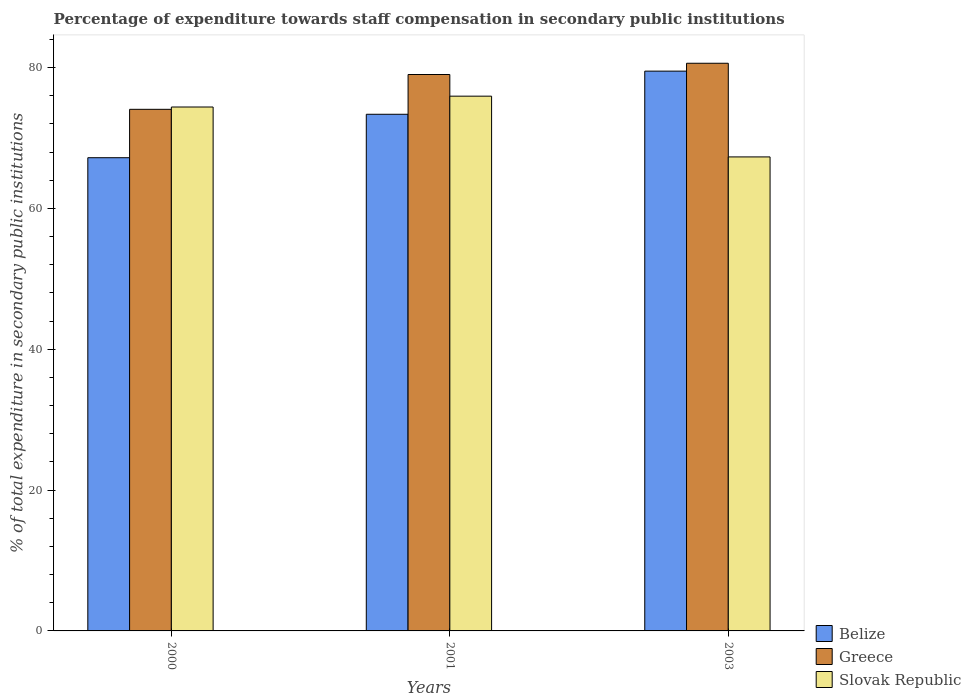How many different coloured bars are there?
Offer a terse response. 3. Are the number of bars per tick equal to the number of legend labels?
Give a very brief answer. Yes. Are the number of bars on each tick of the X-axis equal?
Your response must be concise. Yes. How many bars are there on the 1st tick from the right?
Provide a succinct answer. 3. What is the percentage of expenditure towards staff compensation in Greece in 2003?
Provide a short and direct response. 80.61. Across all years, what is the maximum percentage of expenditure towards staff compensation in Slovak Republic?
Your answer should be compact. 75.94. Across all years, what is the minimum percentage of expenditure towards staff compensation in Slovak Republic?
Offer a very short reply. 67.31. In which year was the percentage of expenditure towards staff compensation in Belize minimum?
Keep it short and to the point. 2000. What is the total percentage of expenditure towards staff compensation in Greece in the graph?
Give a very brief answer. 233.7. What is the difference between the percentage of expenditure towards staff compensation in Belize in 2000 and that in 2001?
Your response must be concise. -6.17. What is the difference between the percentage of expenditure towards staff compensation in Greece in 2000 and the percentage of expenditure towards staff compensation in Belize in 2001?
Make the answer very short. 0.7. What is the average percentage of expenditure towards staff compensation in Belize per year?
Offer a very short reply. 73.35. In the year 2001, what is the difference between the percentage of expenditure towards staff compensation in Belize and percentage of expenditure towards staff compensation in Slovak Republic?
Give a very brief answer. -2.57. In how many years, is the percentage of expenditure towards staff compensation in Greece greater than 60 %?
Provide a short and direct response. 3. What is the ratio of the percentage of expenditure towards staff compensation in Greece in 2001 to that in 2003?
Provide a succinct answer. 0.98. Is the difference between the percentage of expenditure towards staff compensation in Belize in 2000 and 2003 greater than the difference between the percentage of expenditure towards staff compensation in Slovak Republic in 2000 and 2003?
Offer a very short reply. No. What is the difference between the highest and the second highest percentage of expenditure towards staff compensation in Greece?
Give a very brief answer. 1.6. What is the difference between the highest and the lowest percentage of expenditure towards staff compensation in Slovak Republic?
Offer a terse response. 8.63. Is the sum of the percentage of expenditure towards staff compensation in Belize in 2000 and 2003 greater than the maximum percentage of expenditure towards staff compensation in Greece across all years?
Ensure brevity in your answer.  Yes. What does the 2nd bar from the left in 2000 represents?
Ensure brevity in your answer.  Greece. What does the 3rd bar from the right in 2000 represents?
Make the answer very short. Belize. How many bars are there?
Your answer should be compact. 9. Are all the bars in the graph horizontal?
Make the answer very short. No. How many years are there in the graph?
Ensure brevity in your answer.  3. Are the values on the major ticks of Y-axis written in scientific E-notation?
Offer a terse response. No. Does the graph contain grids?
Your answer should be very brief. No. Where does the legend appear in the graph?
Ensure brevity in your answer.  Bottom right. How many legend labels are there?
Your response must be concise. 3. How are the legend labels stacked?
Offer a very short reply. Vertical. What is the title of the graph?
Your answer should be compact. Percentage of expenditure towards staff compensation in secondary public institutions. What is the label or title of the X-axis?
Your answer should be very brief. Years. What is the label or title of the Y-axis?
Provide a succinct answer. % of total expenditure in secondary public institutions. What is the % of total expenditure in secondary public institutions in Belize in 2000?
Your answer should be very brief. 67.2. What is the % of total expenditure in secondary public institutions in Greece in 2000?
Make the answer very short. 74.07. What is the % of total expenditure in secondary public institutions of Slovak Republic in 2000?
Your answer should be very brief. 74.4. What is the % of total expenditure in secondary public institutions in Belize in 2001?
Offer a terse response. 73.37. What is the % of total expenditure in secondary public institutions in Greece in 2001?
Offer a very short reply. 79.02. What is the % of total expenditure in secondary public institutions of Slovak Republic in 2001?
Ensure brevity in your answer.  75.94. What is the % of total expenditure in secondary public institutions in Belize in 2003?
Give a very brief answer. 79.49. What is the % of total expenditure in secondary public institutions of Greece in 2003?
Your answer should be compact. 80.61. What is the % of total expenditure in secondary public institutions in Slovak Republic in 2003?
Your response must be concise. 67.31. Across all years, what is the maximum % of total expenditure in secondary public institutions in Belize?
Your answer should be very brief. 79.49. Across all years, what is the maximum % of total expenditure in secondary public institutions in Greece?
Your answer should be compact. 80.61. Across all years, what is the maximum % of total expenditure in secondary public institutions in Slovak Republic?
Give a very brief answer. 75.94. Across all years, what is the minimum % of total expenditure in secondary public institutions of Belize?
Make the answer very short. 67.2. Across all years, what is the minimum % of total expenditure in secondary public institutions in Greece?
Your answer should be very brief. 74.07. Across all years, what is the minimum % of total expenditure in secondary public institutions of Slovak Republic?
Provide a short and direct response. 67.31. What is the total % of total expenditure in secondary public institutions of Belize in the graph?
Ensure brevity in your answer.  220.06. What is the total % of total expenditure in secondary public institutions in Greece in the graph?
Provide a succinct answer. 233.7. What is the total % of total expenditure in secondary public institutions in Slovak Republic in the graph?
Offer a very short reply. 217.65. What is the difference between the % of total expenditure in secondary public institutions in Belize in 2000 and that in 2001?
Give a very brief answer. -6.17. What is the difference between the % of total expenditure in secondary public institutions in Greece in 2000 and that in 2001?
Keep it short and to the point. -4.94. What is the difference between the % of total expenditure in secondary public institutions of Slovak Republic in 2000 and that in 2001?
Your answer should be compact. -1.54. What is the difference between the % of total expenditure in secondary public institutions of Belize in 2000 and that in 2003?
Offer a very short reply. -12.3. What is the difference between the % of total expenditure in secondary public institutions of Greece in 2000 and that in 2003?
Provide a short and direct response. -6.54. What is the difference between the % of total expenditure in secondary public institutions of Slovak Republic in 2000 and that in 2003?
Your answer should be very brief. 7.09. What is the difference between the % of total expenditure in secondary public institutions in Belize in 2001 and that in 2003?
Make the answer very short. -6.13. What is the difference between the % of total expenditure in secondary public institutions in Greece in 2001 and that in 2003?
Make the answer very short. -1.6. What is the difference between the % of total expenditure in secondary public institutions of Slovak Republic in 2001 and that in 2003?
Provide a short and direct response. 8.63. What is the difference between the % of total expenditure in secondary public institutions of Belize in 2000 and the % of total expenditure in secondary public institutions of Greece in 2001?
Your answer should be compact. -11.82. What is the difference between the % of total expenditure in secondary public institutions in Belize in 2000 and the % of total expenditure in secondary public institutions in Slovak Republic in 2001?
Keep it short and to the point. -8.74. What is the difference between the % of total expenditure in secondary public institutions in Greece in 2000 and the % of total expenditure in secondary public institutions in Slovak Republic in 2001?
Your answer should be compact. -1.87. What is the difference between the % of total expenditure in secondary public institutions in Belize in 2000 and the % of total expenditure in secondary public institutions in Greece in 2003?
Your response must be concise. -13.41. What is the difference between the % of total expenditure in secondary public institutions in Belize in 2000 and the % of total expenditure in secondary public institutions in Slovak Republic in 2003?
Ensure brevity in your answer.  -0.11. What is the difference between the % of total expenditure in secondary public institutions in Greece in 2000 and the % of total expenditure in secondary public institutions in Slovak Republic in 2003?
Make the answer very short. 6.76. What is the difference between the % of total expenditure in secondary public institutions in Belize in 2001 and the % of total expenditure in secondary public institutions in Greece in 2003?
Make the answer very short. -7.24. What is the difference between the % of total expenditure in secondary public institutions in Belize in 2001 and the % of total expenditure in secondary public institutions in Slovak Republic in 2003?
Your response must be concise. 6.06. What is the difference between the % of total expenditure in secondary public institutions in Greece in 2001 and the % of total expenditure in secondary public institutions in Slovak Republic in 2003?
Your answer should be compact. 11.7. What is the average % of total expenditure in secondary public institutions in Belize per year?
Your answer should be very brief. 73.35. What is the average % of total expenditure in secondary public institutions of Greece per year?
Provide a succinct answer. 77.9. What is the average % of total expenditure in secondary public institutions in Slovak Republic per year?
Make the answer very short. 72.55. In the year 2000, what is the difference between the % of total expenditure in secondary public institutions in Belize and % of total expenditure in secondary public institutions in Greece?
Your response must be concise. -6.87. In the year 2000, what is the difference between the % of total expenditure in secondary public institutions in Belize and % of total expenditure in secondary public institutions in Slovak Republic?
Provide a succinct answer. -7.2. In the year 2000, what is the difference between the % of total expenditure in secondary public institutions in Greece and % of total expenditure in secondary public institutions in Slovak Republic?
Keep it short and to the point. -0.33. In the year 2001, what is the difference between the % of total expenditure in secondary public institutions of Belize and % of total expenditure in secondary public institutions of Greece?
Ensure brevity in your answer.  -5.65. In the year 2001, what is the difference between the % of total expenditure in secondary public institutions in Belize and % of total expenditure in secondary public institutions in Slovak Republic?
Provide a succinct answer. -2.57. In the year 2001, what is the difference between the % of total expenditure in secondary public institutions of Greece and % of total expenditure in secondary public institutions of Slovak Republic?
Offer a terse response. 3.08. In the year 2003, what is the difference between the % of total expenditure in secondary public institutions in Belize and % of total expenditure in secondary public institutions in Greece?
Provide a succinct answer. -1.12. In the year 2003, what is the difference between the % of total expenditure in secondary public institutions of Belize and % of total expenditure in secondary public institutions of Slovak Republic?
Offer a very short reply. 12.18. In the year 2003, what is the difference between the % of total expenditure in secondary public institutions in Greece and % of total expenditure in secondary public institutions in Slovak Republic?
Offer a terse response. 13.3. What is the ratio of the % of total expenditure in secondary public institutions of Belize in 2000 to that in 2001?
Your answer should be very brief. 0.92. What is the ratio of the % of total expenditure in secondary public institutions of Greece in 2000 to that in 2001?
Provide a succinct answer. 0.94. What is the ratio of the % of total expenditure in secondary public institutions in Slovak Republic in 2000 to that in 2001?
Provide a short and direct response. 0.98. What is the ratio of the % of total expenditure in secondary public institutions of Belize in 2000 to that in 2003?
Your answer should be compact. 0.85. What is the ratio of the % of total expenditure in secondary public institutions in Greece in 2000 to that in 2003?
Provide a succinct answer. 0.92. What is the ratio of the % of total expenditure in secondary public institutions of Slovak Republic in 2000 to that in 2003?
Keep it short and to the point. 1.11. What is the ratio of the % of total expenditure in secondary public institutions in Belize in 2001 to that in 2003?
Keep it short and to the point. 0.92. What is the ratio of the % of total expenditure in secondary public institutions in Greece in 2001 to that in 2003?
Offer a very short reply. 0.98. What is the ratio of the % of total expenditure in secondary public institutions in Slovak Republic in 2001 to that in 2003?
Your response must be concise. 1.13. What is the difference between the highest and the second highest % of total expenditure in secondary public institutions in Belize?
Your answer should be compact. 6.13. What is the difference between the highest and the second highest % of total expenditure in secondary public institutions in Greece?
Provide a succinct answer. 1.6. What is the difference between the highest and the second highest % of total expenditure in secondary public institutions of Slovak Republic?
Provide a succinct answer. 1.54. What is the difference between the highest and the lowest % of total expenditure in secondary public institutions of Belize?
Keep it short and to the point. 12.3. What is the difference between the highest and the lowest % of total expenditure in secondary public institutions of Greece?
Keep it short and to the point. 6.54. What is the difference between the highest and the lowest % of total expenditure in secondary public institutions of Slovak Republic?
Offer a terse response. 8.63. 